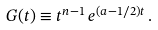<formula> <loc_0><loc_0><loc_500><loc_500>G ( t ) \equiv t ^ { n - 1 } \, { e } ^ { ( a - 1 / 2 ) t } \, .</formula> 